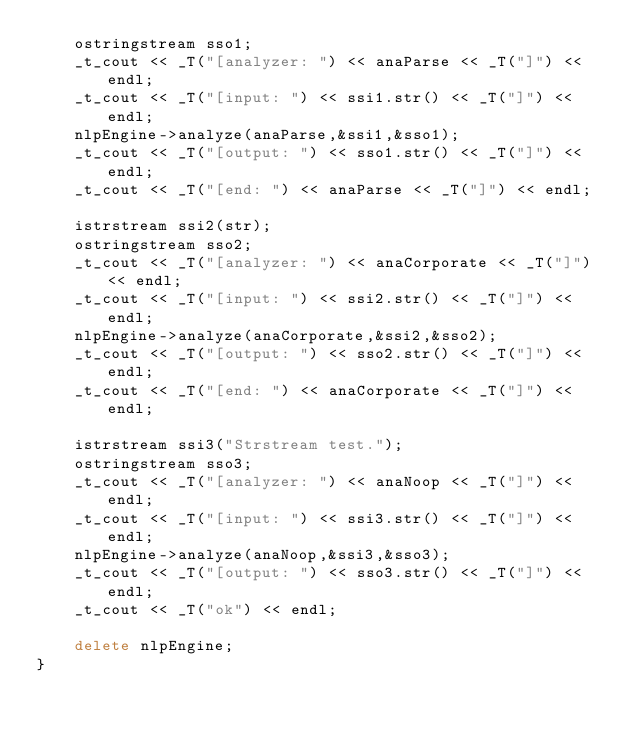Convert code to text. <code><loc_0><loc_0><loc_500><loc_500><_C++_>    ostringstream sso1;
    _t_cout << _T("[analyzer: ") << anaParse << _T("]") << endl;
    _t_cout << _T("[input: ") << ssi1.str() << _T("]") << endl;
    nlpEngine->analyze(anaParse,&ssi1,&sso1);
    _t_cout << _T("[output: ") << sso1.str() << _T("]") << endl;
    _t_cout << _T("[end: ") << anaParse << _T("]") << endl;

    istrstream ssi2(str);
    ostringstream sso2;
    _t_cout << _T("[analyzer: ") << anaCorporate << _T("]") << endl;
    _t_cout << _T("[input: ") << ssi2.str() << _T("]") << endl;
    nlpEngine->analyze(anaCorporate,&ssi2,&sso2);
    _t_cout << _T("[output: ") << sso2.str() << _T("]") << endl;
    _t_cout << _T("[end: ") << anaCorporate << _T("]") << endl;

    istrstream ssi3("Strstream test.");
    ostringstream sso3;
    _t_cout << _T("[analyzer: ") << anaNoop << _T("]") << endl;
    _t_cout << _T("[input: ") << ssi3.str() << _T("]") << endl;
    nlpEngine->analyze(anaNoop,&ssi3,&sso3);
    _t_cout << _T("[output: ") << sso3.str() << _T("]") << endl;
    _t_cout << _T("ok") << endl;

    delete nlpEngine;
}
</code> 